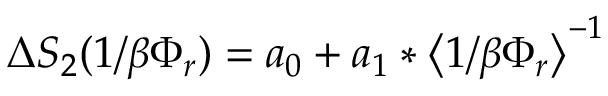Convert formula to latex. <formula><loc_0><loc_0><loc_500><loc_500>\Delta S _ { 2 } ( 1 / \beta \Phi _ { r } ) = a _ { 0 } + a _ { 1 } * \Big < 1 / \beta \Phi _ { r } \Big > ^ { - 1 }</formula> 